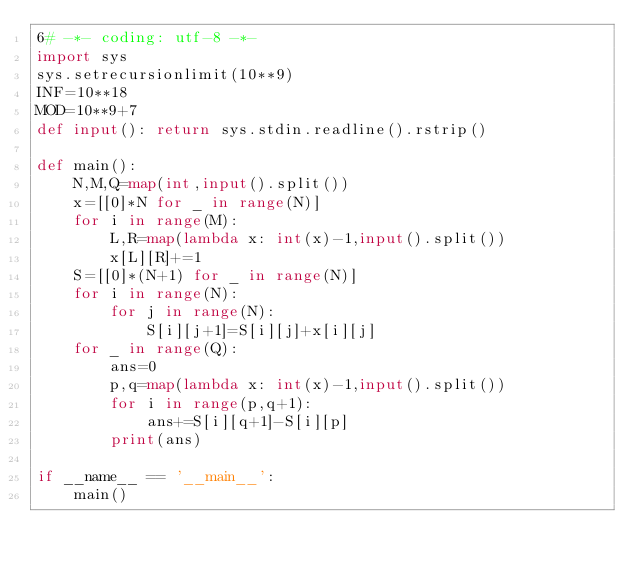<code> <loc_0><loc_0><loc_500><loc_500><_Python_>6# -*- coding: utf-8 -*-
import sys
sys.setrecursionlimit(10**9)
INF=10**18
MOD=10**9+7
def input(): return sys.stdin.readline().rstrip()

def main():
    N,M,Q=map(int,input().split())
    x=[[0]*N for _ in range(N)]
    for i in range(M):
        L,R=map(lambda x: int(x)-1,input().split())
        x[L][R]+=1
    S=[[0]*(N+1) for _ in range(N)]
    for i in range(N):
        for j in range(N):
            S[i][j+1]=S[i][j]+x[i][j]
    for _ in range(Q):
        ans=0
        p,q=map(lambda x: int(x)-1,input().split())
        for i in range(p,q+1):
            ans+=S[i][q+1]-S[i][p]
        print(ans)

if __name__ == '__main__':
    main()
</code> 